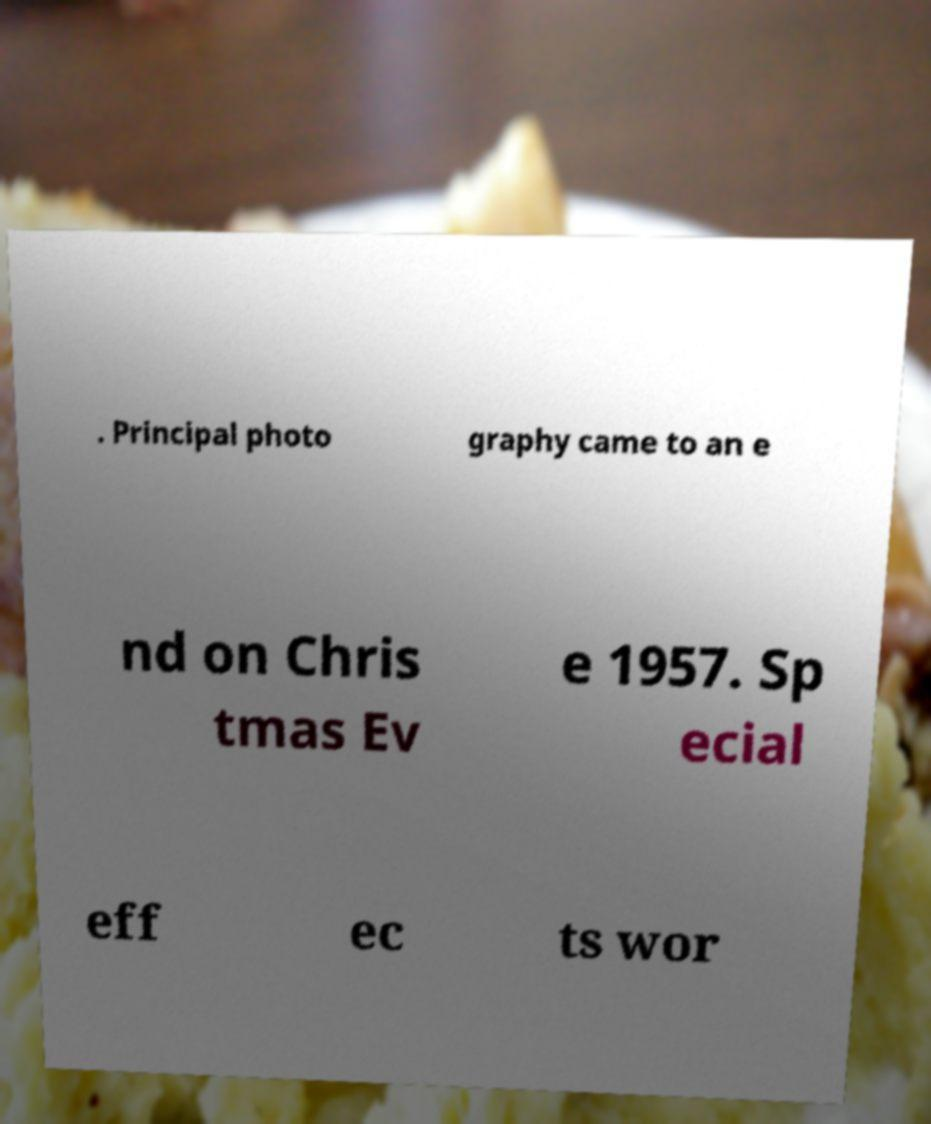Please read and relay the text visible in this image. What does it say? . Principal photo graphy came to an e nd on Chris tmas Ev e 1957. Sp ecial eff ec ts wor 